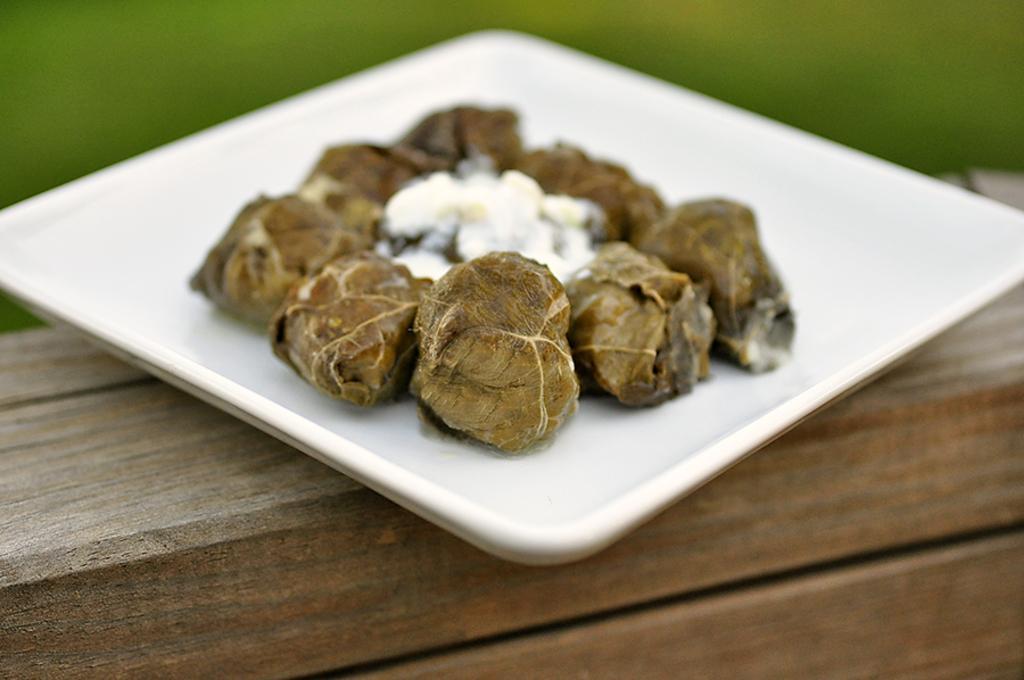Could you give a brief overview of what you see in this image? In this image there is a food item on the plate , on the wooden board, and there is blur background. 